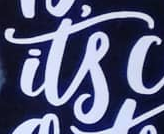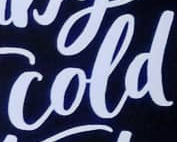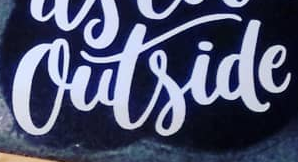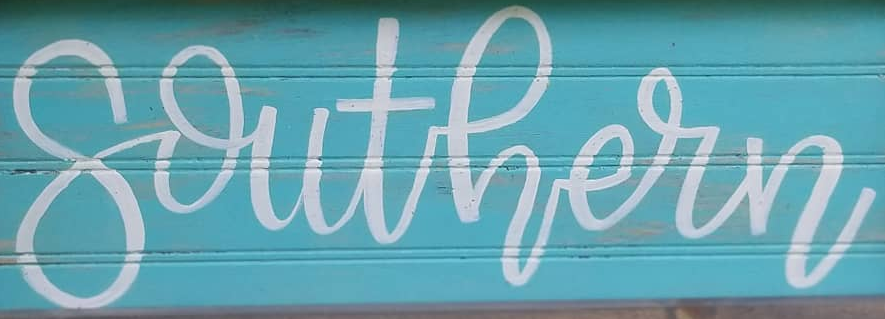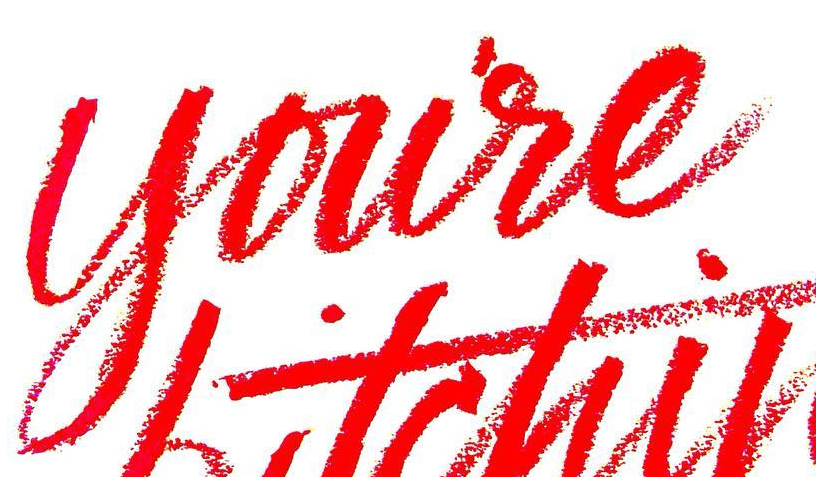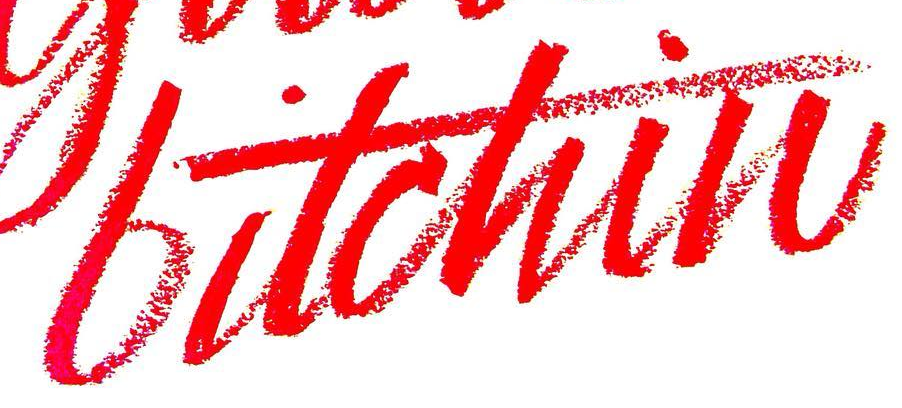Identify the words shown in these images in order, separated by a semicolon. its; cold; outside; southern; youre; bitchin 